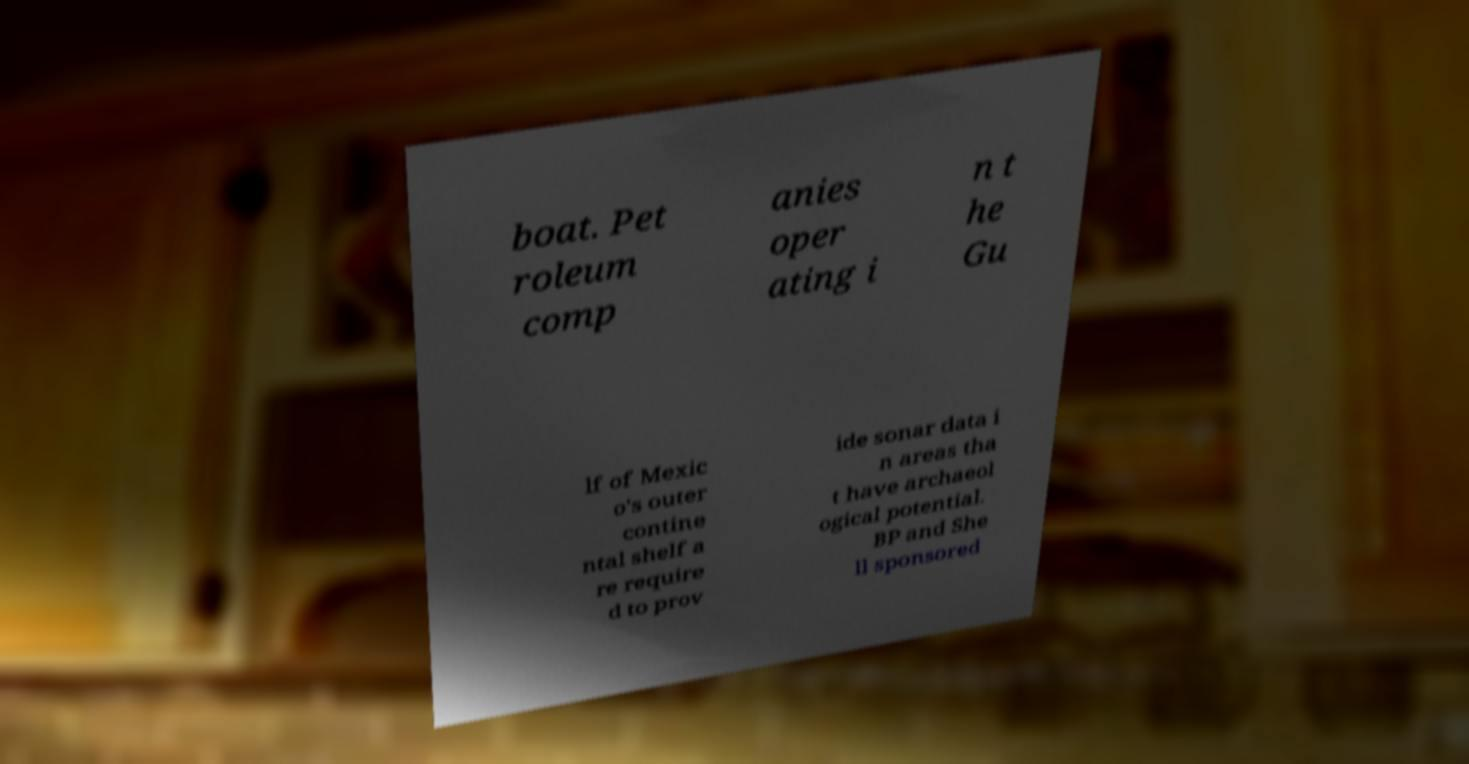Please identify and transcribe the text found in this image. boat. Pet roleum comp anies oper ating i n t he Gu lf of Mexic o's outer contine ntal shelf a re require d to prov ide sonar data i n areas tha t have archaeol ogical potential. BP and She ll sponsored 